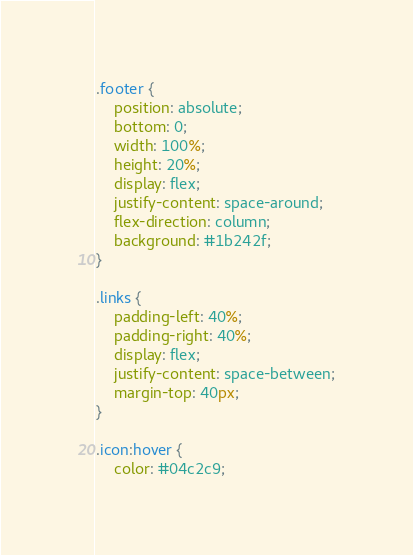Convert code to text. <code><loc_0><loc_0><loc_500><loc_500><_CSS_>.footer {
    position: absolute;
    bottom: 0;
    width: 100%;
    height: 20%;
    display: flex;
    justify-content: space-around;
    flex-direction: column;
    background: #1b242f;
}

.links {
    padding-left: 40%;
    padding-right: 40%;
    display: flex;
    justify-content: space-between;
    margin-top: 40px;
}

.icon:hover {
    color: #04c2c9;</code> 